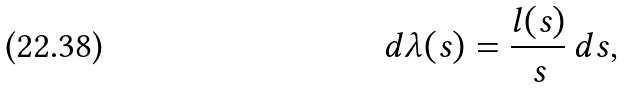Convert formula to latex. <formula><loc_0><loc_0><loc_500><loc_500>d \lambda ( s ) = \frac { l ( s ) } { s } \, d s ,</formula> 